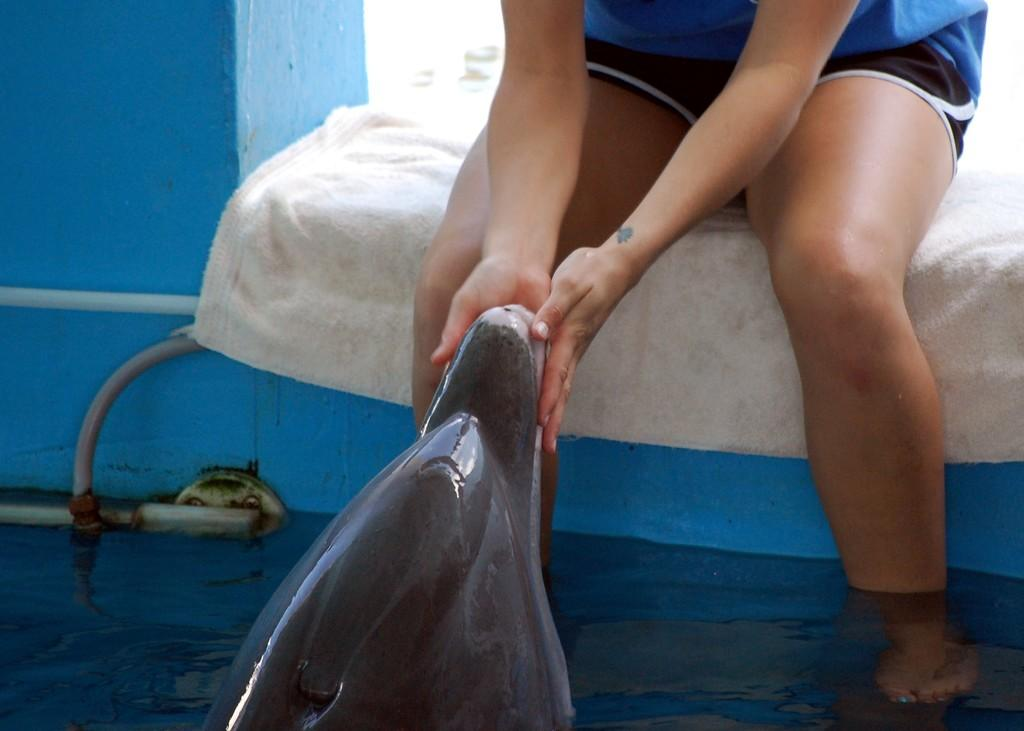What is the person in the image sitting on? The person is sitting on a cloth in the image. Where is the person located in relation to the pool? The person is in front of a pool in the image. What type of animal can be seen in the pool? There is a dolphin in the pool. What type of sock is the person wearing in the image? There is no sock visible in the image; the person is sitting on a cloth. 